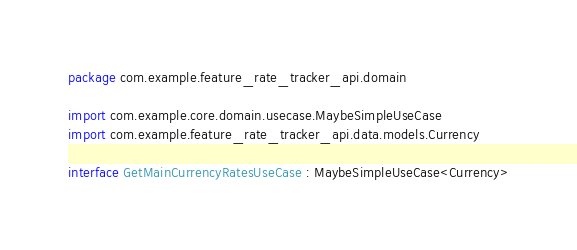<code> <loc_0><loc_0><loc_500><loc_500><_Kotlin_>package com.example.feature_rate_tracker_api.domain

import com.example.core.domain.usecase.MaybeSimpleUseCase
import com.example.feature_rate_tracker_api.data.models.Currency

interface GetMainCurrencyRatesUseCase : MaybeSimpleUseCase<Currency></code> 